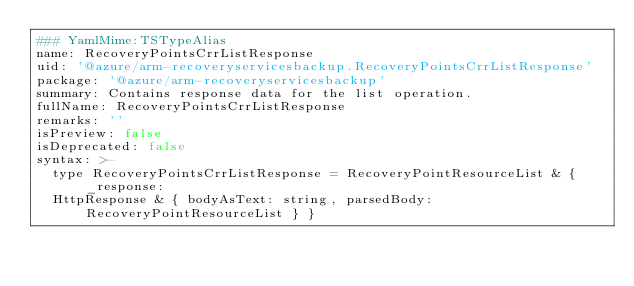Convert code to text. <code><loc_0><loc_0><loc_500><loc_500><_YAML_>### YamlMime:TSTypeAlias
name: RecoveryPointsCrrListResponse
uid: '@azure/arm-recoveryservicesbackup.RecoveryPointsCrrListResponse'
package: '@azure/arm-recoveryservicesbackup'
summary: Contains response data for the list operation.
fullName: RecoveryPointsCrrListResponse
remarks: ''
isPreview: false
isDeprecated: false
syntax: >-
  type RecoveryPointsCrrListResponse = RecoveryPointResourceList & { _response:
  HttpResponse & { bodyAsText: string, parsedBody: RecoveryPointResourceList } }
</code> 